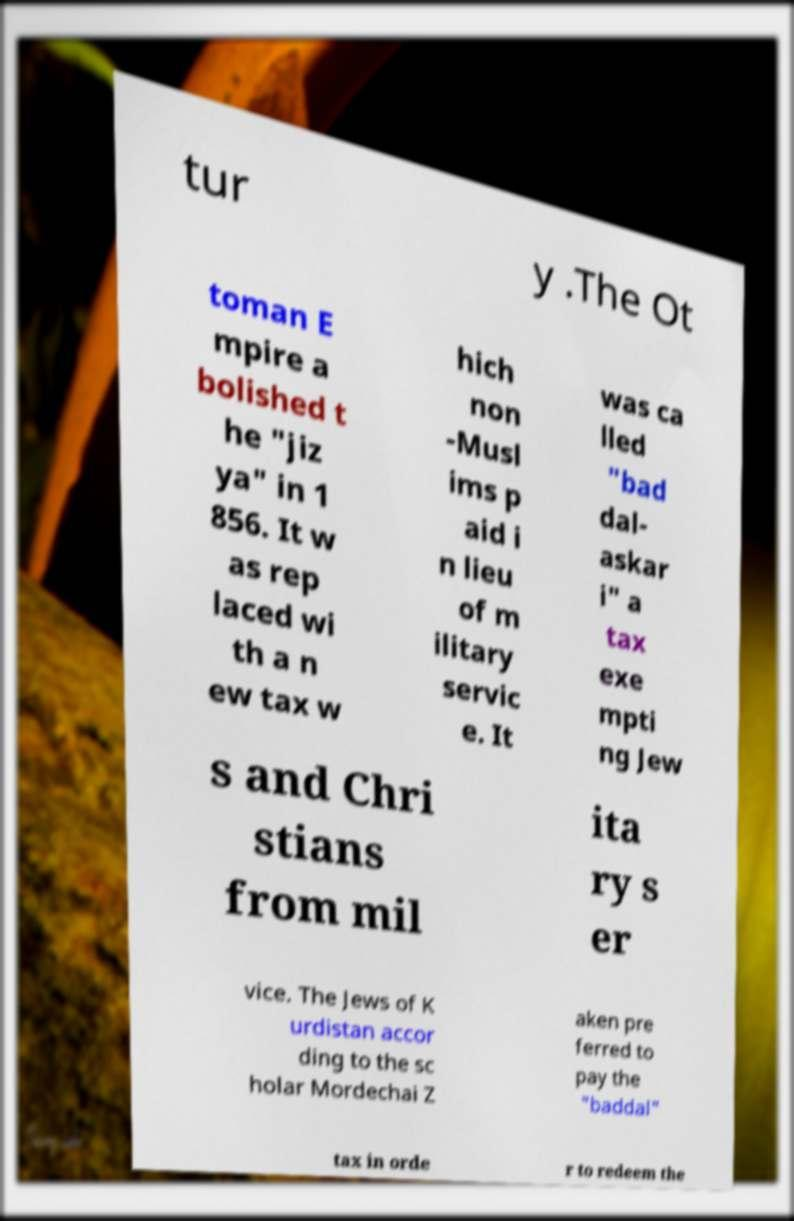Can you read and provide the text displayed in the image?This photo seems to have some interesting text. Can you extract and type it out for me? tur y .The Ot toman E mpire a bolished t he "jiz ya" in 1 856. It w as rep laced wi th a n ew tax w hich non -Musl ims p aid i n lieu of m ilitary servic e. It was ca lled "bad dal- askar i" a tax exe mpti ng Jew s and Chri stians from mil ita ry s er vice. The Jews of K urdistan accor ding to the sc holar Mordechai Z aken pre ferred to pay the "baddal" tax in orde r to redeem the 